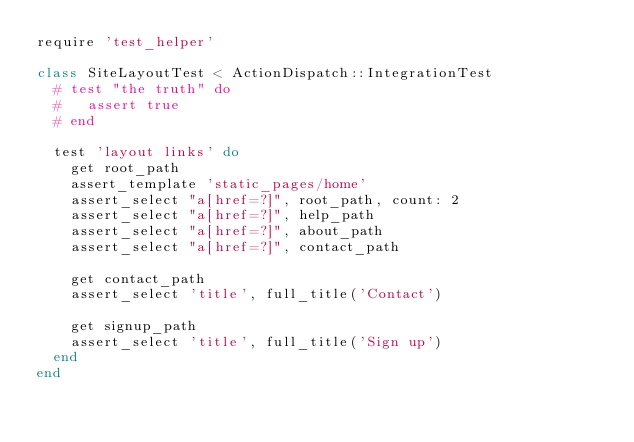Convert code to text. <code><loc_0><loc_0><loc_500><loc_500><_Ruby_>require 'test_helper'

class SiteLayoutTest < ActionDispatch::IntegrationTest
  # test "the truth" do
  #   assert true
  # end

  test 'layout links' do
    get root_path
    assert_template 'static_pages/home'
    assert_select "a[href=?]", root_path, count: 2
    assert_select "a[href=?]", help_path
    assert_select "a[href=?]", about_path
    assert_select "a[href=?]", contact_path

    get contact_path
    assert_select 'title', full_title('Contact')

    get signup_path
    assert_select 'title', full_title('Sign up')
  end
end
</code> 